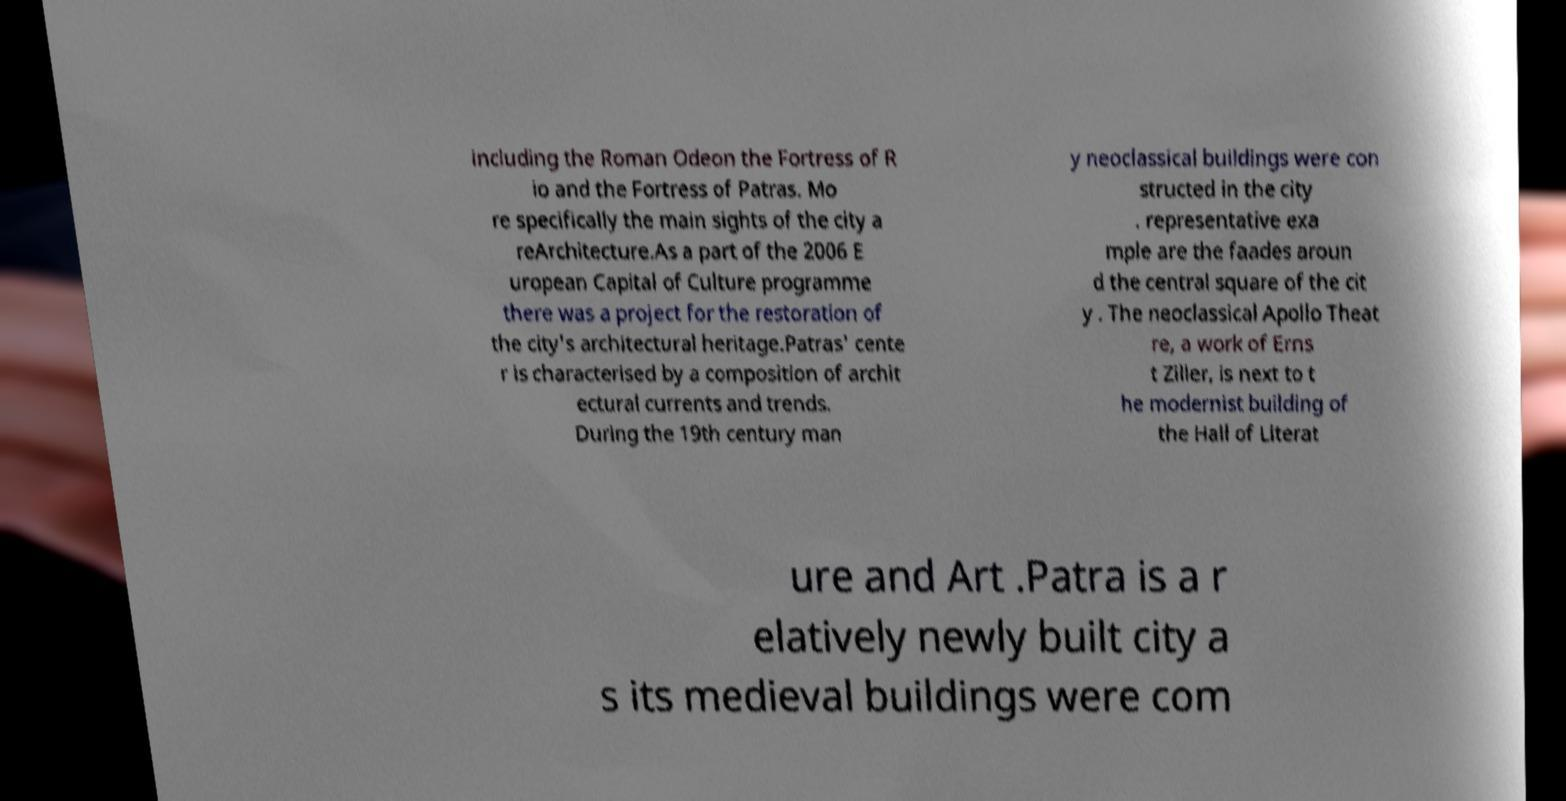There's text embedded in this image that I need extracted. Can you transcribe it verbatim? including the Roman Odeon the Fortress of R io and the Fortress of Patras. Mo re specifically the main sights of the city a reArchitecture.As a part of the 2006 E uropean Capital of Culture programme there was a project for the restoration of the city's architectural heritage.Patras' cente r is characterised by a composition of archit ectural currents and trends. During the 19th century man y neoclassical buildings were con structed in the city . representative exa mple are the faades aroun d the central square of the cit y . The neoclassical Apollo Theat re, a work of Erns t Ziller, is next to t he modernist building of the Hall of Literat ure and Art .Patra is a r elatively newly built city a s its medieval buildings were com 